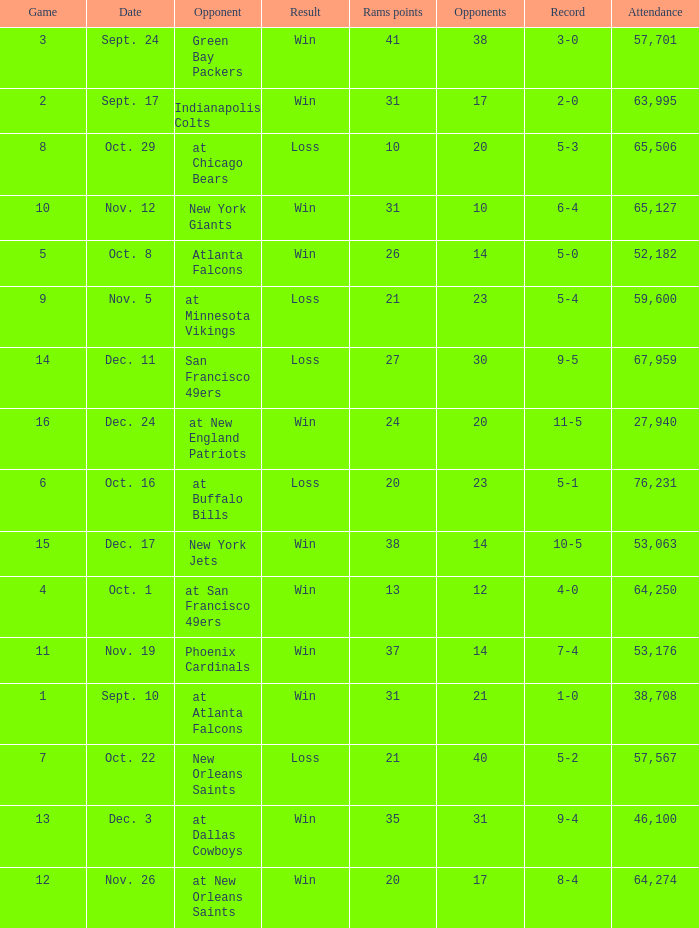What was the attendance where the record was 8-4? 64274.0. 